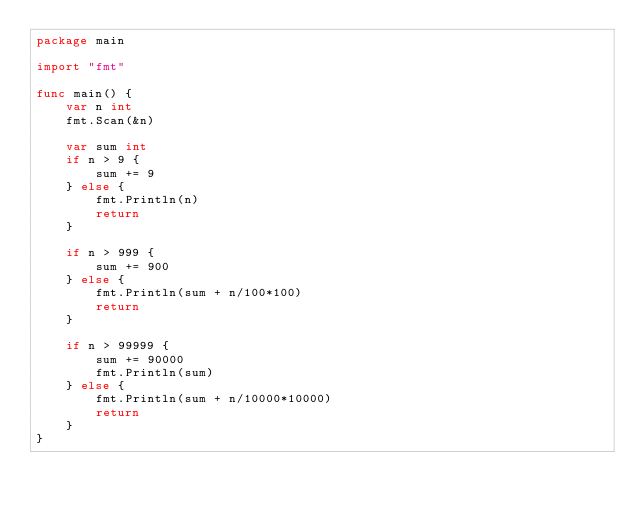<code> <loc_0><loc_0><loc_500><loc_500><_Go_>package main

import "fmt"

func main() {
	var n int
	fmt.Scan(&n)

	var sum int
	if n > 9 {
		sum += 9
	} else {
		fmt.Println(n)
		return
	}

	if n > 999 {
		sum += 900
	} else {
		fmt.Println(sum + n/100*100)
		return
	}

	if n > 99999 {
		sum += 90000
		fmt.Println(sum)
	} else {
		fmt.Println(sum + n/10000*10000)
		return
	}
}
</code> 